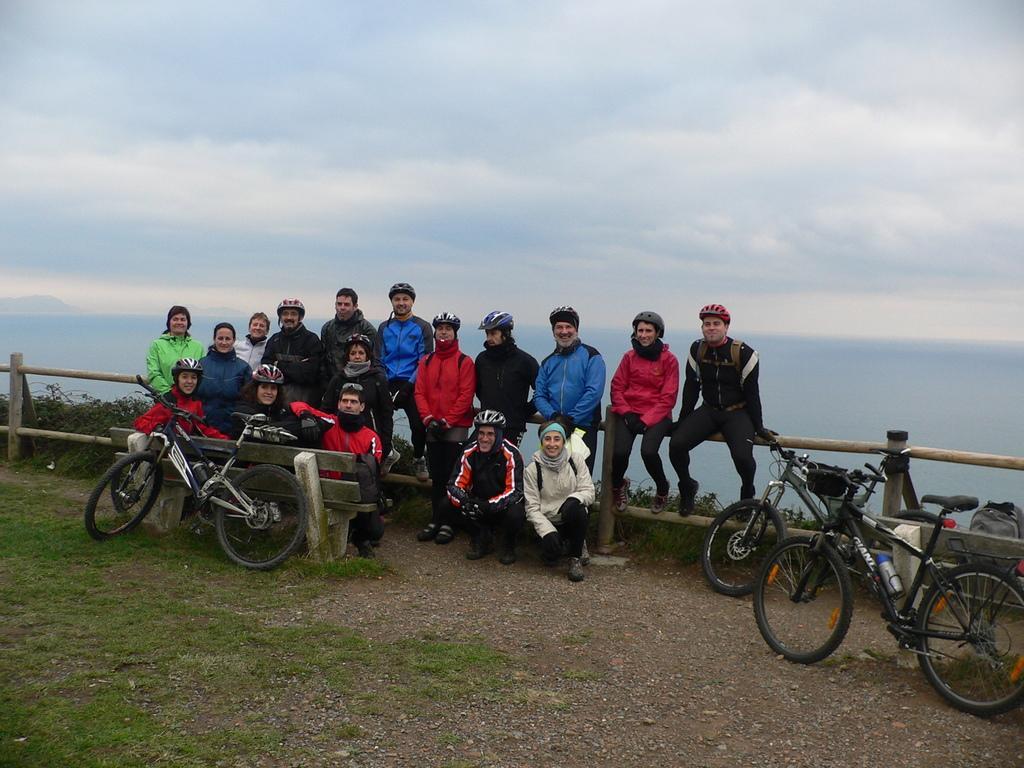Can you describe this image briefly? In this image I can see three bicycles and a group of people are sitting on a fence. In the background I can see water and the sky. This image is taken may be near the ocean. 